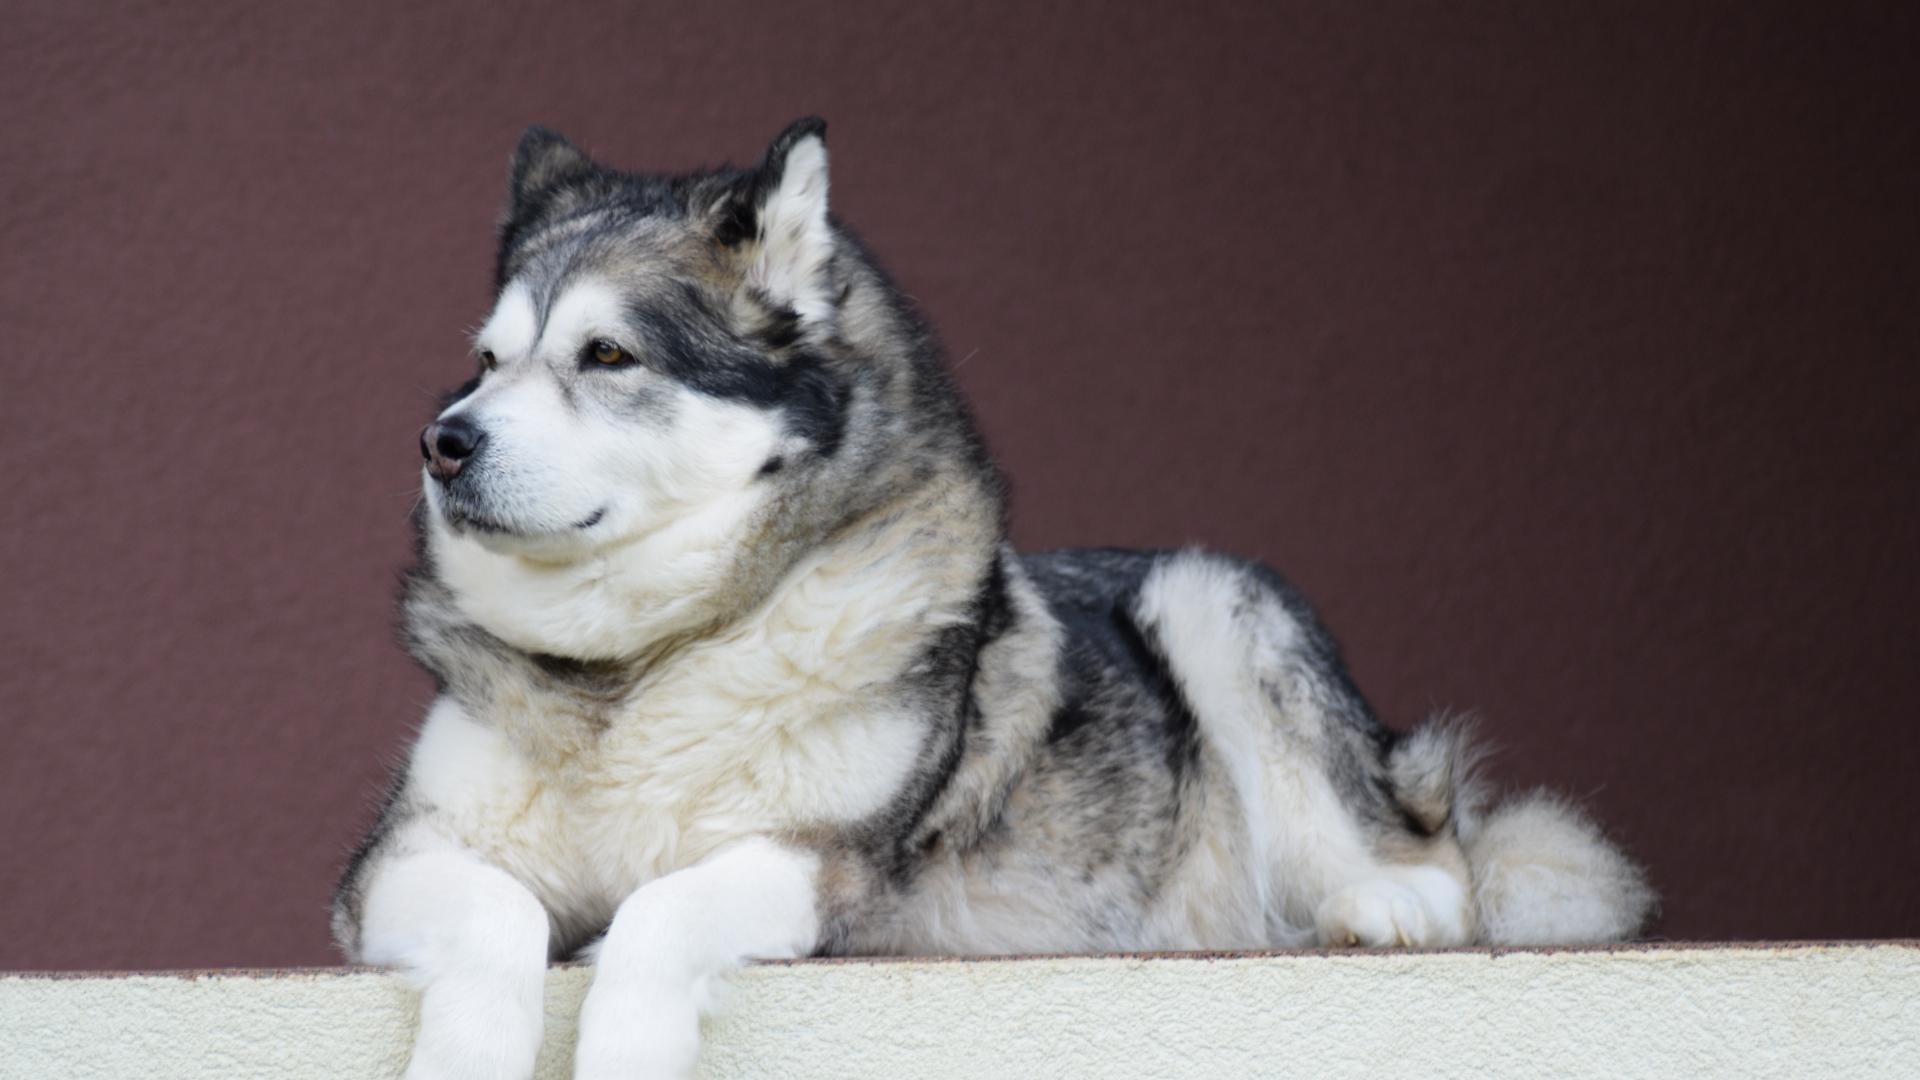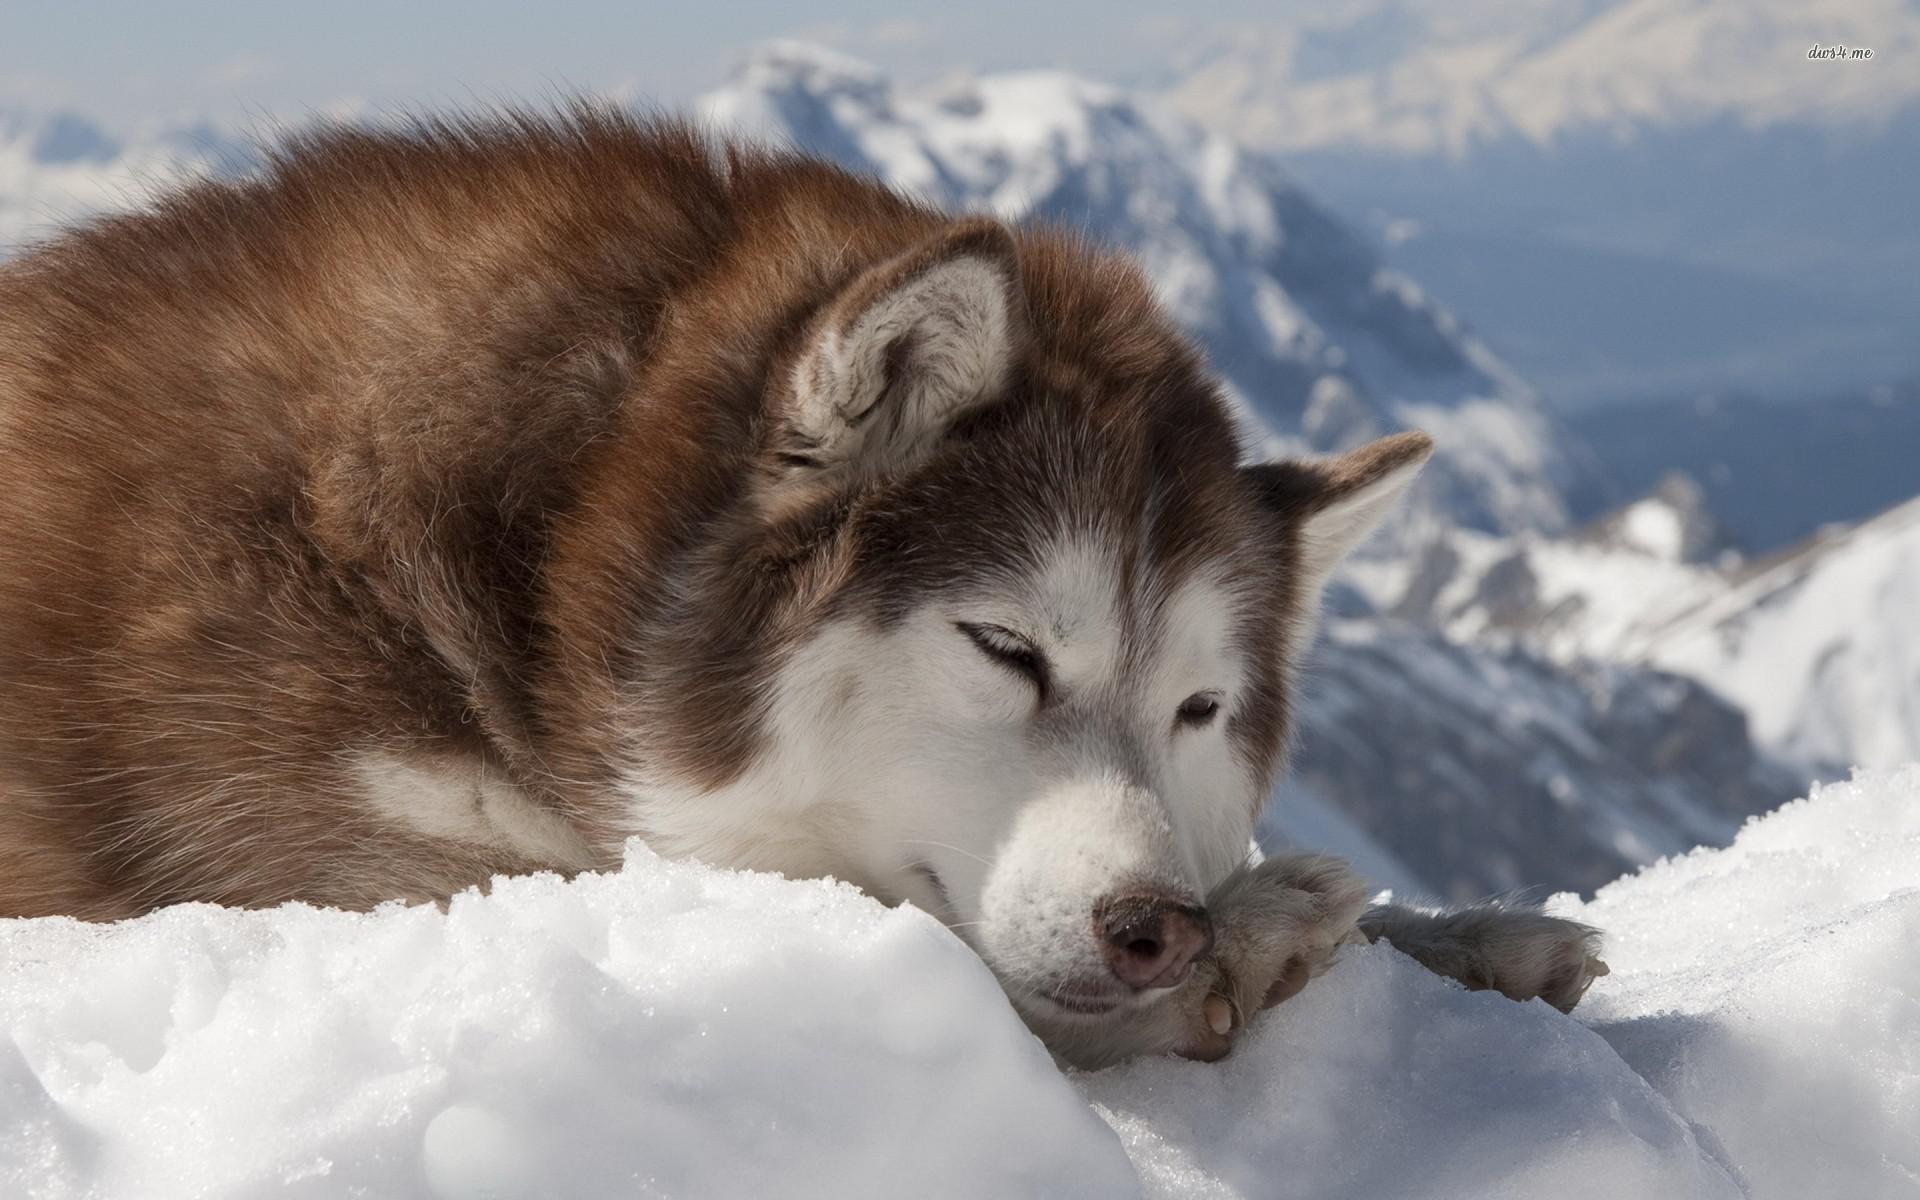The first image is the image on the left, the second image is the image on the right. Considering the images on both sides, is "One husky has its mouth open but is not snarling, and a different husky wears something blue around itself and has upright ears." valid? Answer yes or no. No. The first image is the image on the left, the second image is the image on the right. Examine the images to the left and right. Is the description "There is a dog with its mouth open in each image." accurate? Answer yes or no. No. 